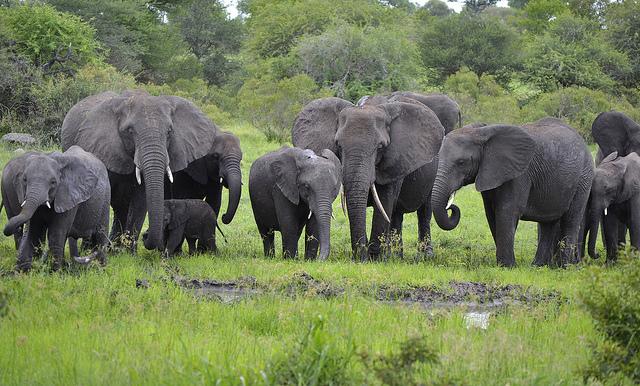Is there a place for the elephants to drink?
Quick response, please. Yes. What is this group of elephants called?
Be succinct. Herd. How many of these elephants have tusks?
Concise answer only. 5. 